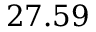<formula> <loc_0><loc_0><loc_500><loc_500>2 7 . 5 9</formula> 